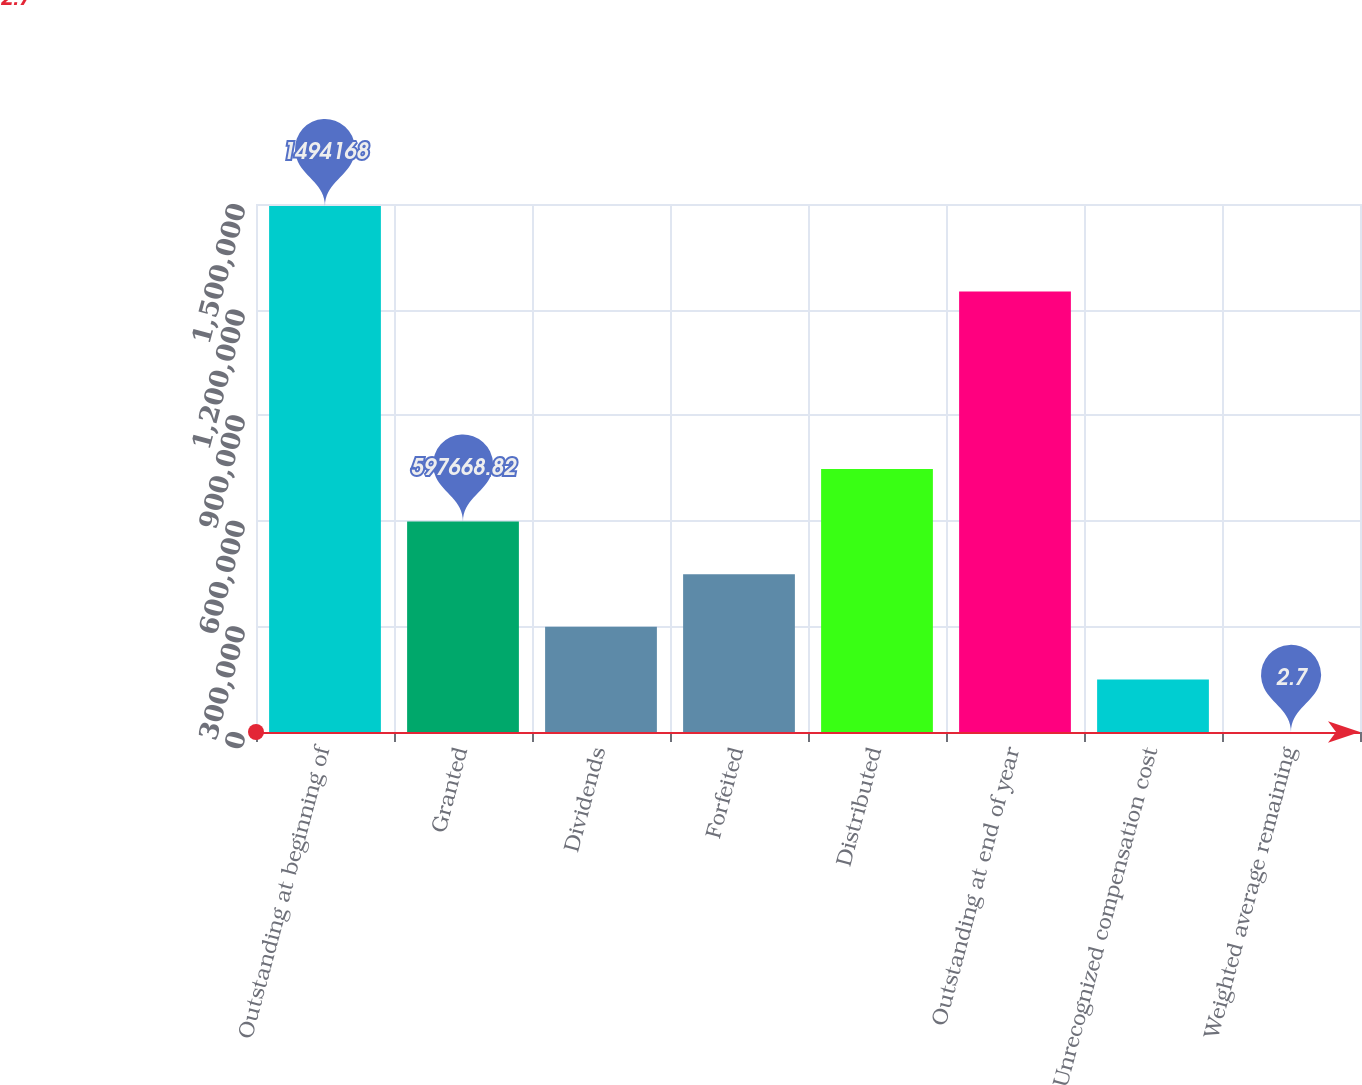<chart> <loc_0><loc_0><loc_500><loc_500><bar_chart><fcel>Outstanding at beginning of<fcel>Granted<fcel>Dividends<fcel>Forfeited<fcel>Distributed<fcel>Outstanding at end of year<fcel>Unrecognized compensation cost<fcel>Weighted average remaining<nl><fcel>1.49417e+06<fcel>597669<fcel>298836<fcel>448252<fcel>747085<fcel>1.25119e+06<fcel>149419<fcel>2.7<nl></chart> 